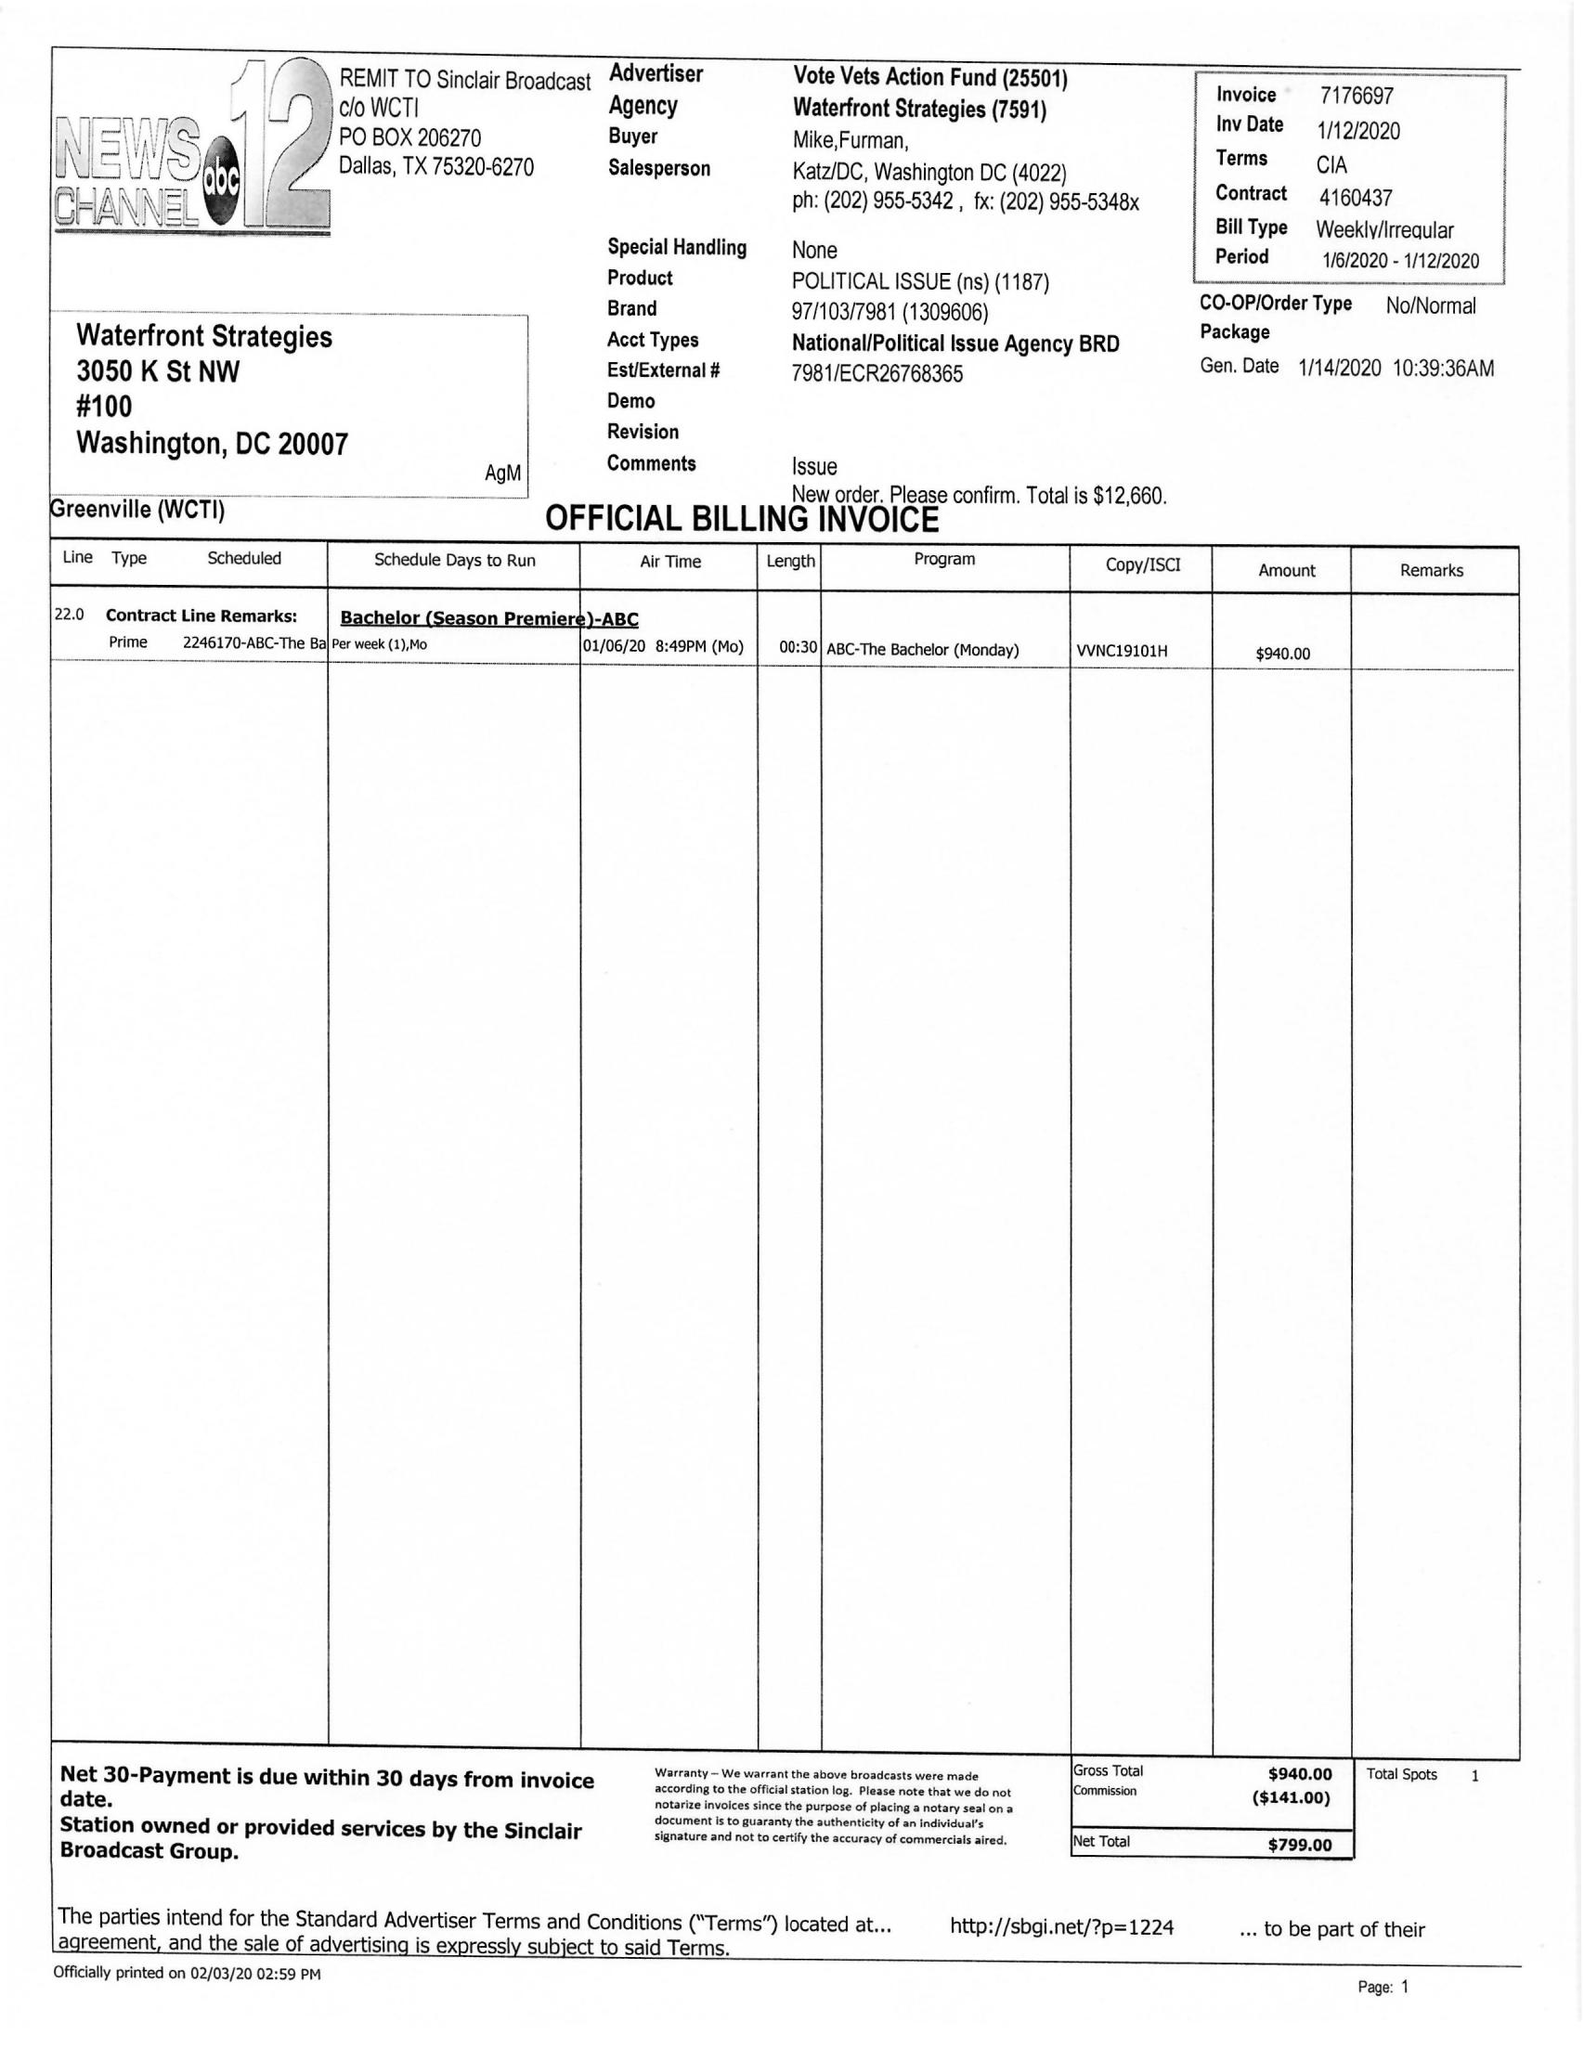What is the value for the gross_amount?
Answer the question using a single word or phrase. 940.00 